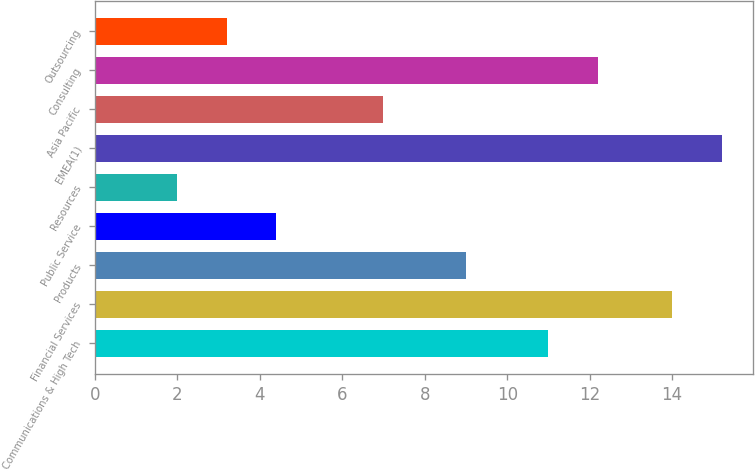Convert chart to OTSL. <chart><loc_0><loc_0><loc_500><loc_500><bar_chart><fcel>Communications & High Tech<fcel>Financial Services<fcel>Products<fcel>Public Service<fcel>Resources<fcel>EMEA(1)<fcel>Asia Pacific<fcel>Consulting<fcel>Outsourcing<nl><fcel>11<fcel>14<fcel>9<fcel>4.4<fcel>2<fcel>15.2<fcel>7<fcel>12.2<fcel>3.2<nl></chart> 